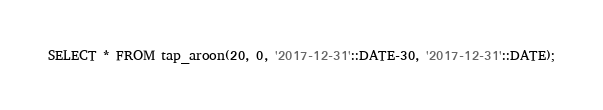Convert code to text. <code><loc_0><loc_0><loc_500><loc_500><_SQL_>SELECT * FROM tap_aroon(20, 0, '2017-12-31'::DATE-30, '2017-12-31'::DATE);
</code> 